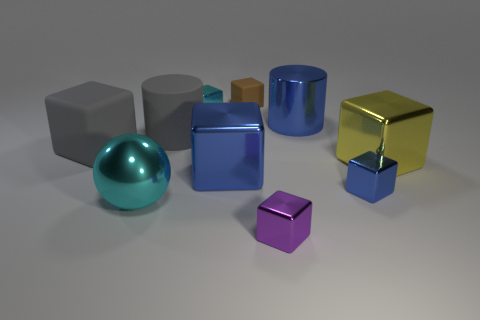Subtract all tiny purple cubes. How many cubes are left? 6 Subtract all purple blocks. How many blocks are left? 6 Subtract 2 cubes. How many cubes are left? 5 Subtract all brown cubes. Subtract all purple cylinders. How many cubes are left? 6 Subtract all cylinders. How many objects are left? 8 Subtract all big blue objects. Subtract all small green metallic blocks. How many objects are left? 8 Add 8 blue blocks. How many blue blocks are left? 10 Add 1 tiny purple objects. How many tiny purple objects exist? 2 Subtract 1 cyan balls. How many objects are left? 9 